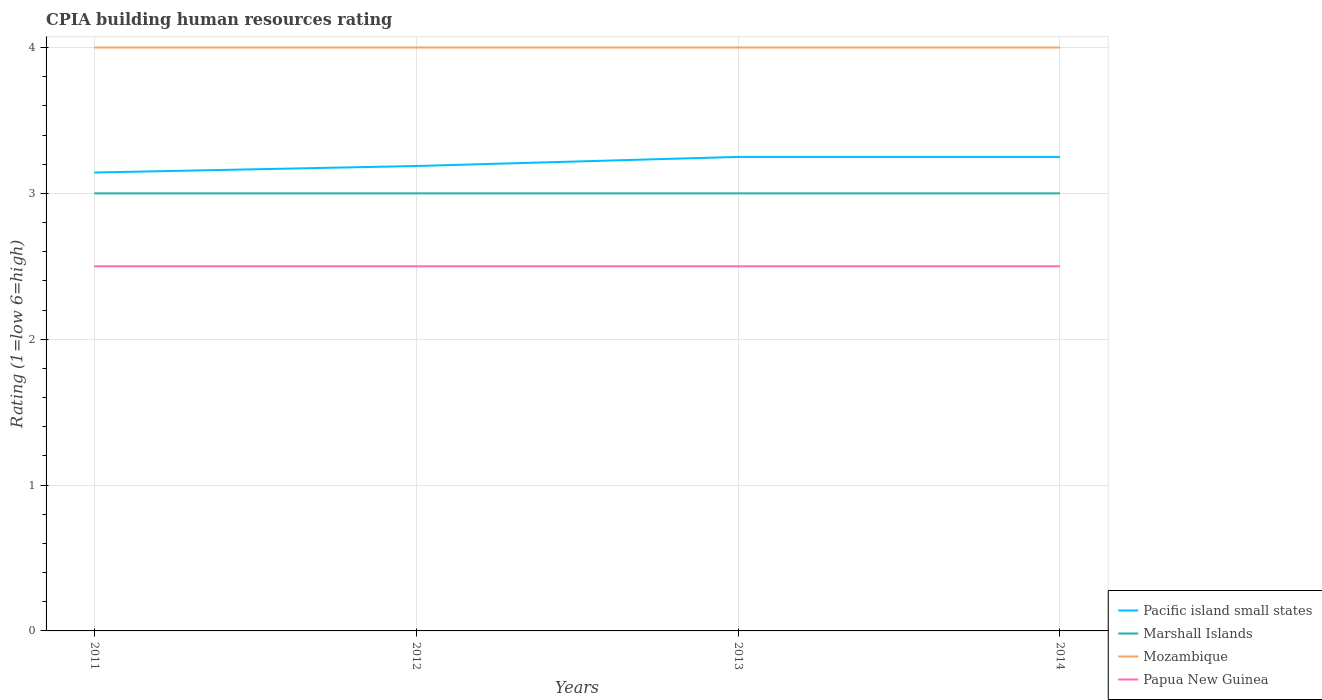How many different coloured lines are there?
Offer a terse response. 4. Is the number of lines equal to the number of legend labels?
Your response must be concise. Yes. What is the total CPIA rating in Pacific island small states in the graph?
Your answer should be compact. -0.11. What is the difference between the highest and the second highest CPIA rating in Marshall Islands?
Ensure brevity in your answer.  0. What is the difference between the highest and the lowest CPIA rating in Mozambique?
Your answer should be very brief. 0. Is the CPIA rating in Mozambique strictly greater than the CPIA rating in Marshall Islands over the years?
Keep it short and to the point. No. How many years are there in the graph?
Keep it short and to the point. 4. What is the difference between two consecutive major ticks on the Y-axis?
Ensure brevity in your answer.  1. Are the values on the major ticks of Y-axis written in scientific E-notation?
Keep it short and to the point. No. Does the graph contain any zero values?
Offer a terse response. No. Does the graph contain grids?
Offer a very short reply. Yes. What is the title of the graph?
Offer a very short reply. CPIA building human resources rating. What is the label or title of the X-axis?
Ensure brevity in your answer.  Years. What is the Rating (1=low 6=high) of Pacific island small states in 2011?
Make the answer very short. 3.14. What is the Rating (1=low 6=high) in Marshall Islands in 2011?
Your answer should be compact. 3. What is the Rating (1=low 6=high) of Papua New Guinea in 2011?
Your answer should be very brief. 2.5. What is the Rating (1=low 6=high) of Pacific island small states in 2012?
Make the answer very short. 3.19. What is the Rating (1=low 6=high) of Mozambique in 2012?
Ensure brevity in your answer.  4. What is the Rating (1=low 6=high) in Pacific island small states in 2013?
Provide a short and direct response. 3.25. What is the Rating (1=low 6=high) of Marshall Islands in 2013?
Your answer should be very brief. 3. What is the Rating (1=low 6=high) in Mozambique in 2013?
Provide a succinct answer. 4. What is the Rating (1=low 6=high) of Papua New Guinea in 2013?
Ensure brevity in your answer.  2.5. Across all years, what is the maximum Rating (1=low 6=high) of Pacific island small states?
Offer a terse response. 3.25. Across all years, what is the minimum Rating (1=low 6=high) in Pacific island small states?
Ensure brevity in your answer.  3.14. Across all years, what is the minimum Rating (1=low 6=high) in Marshall Islands?
Provide a succinct answer. 3. Across all years, what is the minimum Rating (1=low 6=high) in Mozambique?
Ensure brevity in your answer.  4. Across all years, what is the minimum Rating (1=low 6=high) of Papua New Guinea?
Your response must be concise. 2.5. What is the total Rating (1=low 6=high) of Pacific island small states in the graph?
Ensure brevity in your answer.  12.83. What is the total Rating (1=low 6=high) of Marshall Islands in the graph?
Your answer should be very brief. 12. What is the total Rating (1=low 6=high) in Papua New Guinea in the graph?
Offer a terse response. 10. What is the difference between the Rating (1=low 6=high) in Pacific island small states in 2011 and that in 2012?
Your answer should be very brief. -0.04. What is the difference between the Rating (1=low 6=high) of Marshall Islands in 2011 and that in 2012?
Keep it short and to the point. 0. What is the difference between the Rating (1=low 6=high) in Mozambique in 2011 and that in 2012?
Your answer should be compact. 0. What is the difference between the Rating (1=low 6=high) in Pacific island small states in 2011 and that in 2013?
Ensure brevity in your answer.  -0.11. What is the difference between the Rating (1=low 6=high) in Marshall Islands in 2011 and that in 2013?
Your answer should be compact. 0. What is the difference between the Rating (1=low 6=high) in Pacific island small states in 2011 and that in 2014?
Provide a succinct answer. -0.11. What is the difference between the Rating (1=low 6=high) of Papua New Guinea in 2011 and that in 2014?
Your answer should be compact. 0. What is the difference between the Rating (1=low 6=high) of Pacific island small states in 2012 and that in 2013?
Offer a very short reply. -0.06. What is the difference between the Rating (1=low 6=high) of Mozambique in 2012 and that in 2013?
Provide a short and direct response. 0. What is the difference between the Rating (1=low 6=high) in Pacific island small states in 2012 and that in 2014?
Offer a terse response. -0.06. What is the difference between the Rating (1=low 6=high) of Marshall Islands in 2012 and that in 2014?
Your answer should be very brief. 0. What is the difference between the Rating (1=low 6=high) of Mozambique in 2012 and that in 2014?
Provide a short and direct response. 0. What is the difference between the Rating (1=low 6=high) in Marshall Islands in 2013 and that in 2014?
Your response must be concise. 0. What is the difference between the Rating (1=low 6=high) in Mozambique in 2013 and that in 2014?
Make the answer very short. 0. What is the difference between the Rating (1=low 6=high) of Pacific island small states in 2011 and the Rating (1=low 6=high) of Marshall Islands in 2012?
Provide a succinct answer. 0.14. What is the difference between the Rating (1=low 6=high) of Pacific island small states in 2011 and the Rating (1=low 6=high) of Mozambique in 2012?
Provide a succinct answer. -0.86. What is the difference between the Rating (1=low 6=high) in Pacific island small states in 2011 and the Rating (1=low 6=high) in Papua New Guinea in 2012?
Give a very brief answer. 0.64. What is the difference between the Rating (1=low 6=high) in Marshall Islands in 2011 and the Rating (1=low 6=high) in Mozambique in 2012?
Ensure brevity in your answer.  -1. What is the difference between the Rating (1=low 6=high) in Marshall Islands in 2011 and the Rating (1=low 6=high) in Papua New Guinea in 2012?
Your answer should be very brief. 0.5. What is the difference between the Rating (1=low 6=high) in Pacific island small states in 2011 and the Rating (1=low 6=high) in Marshall Islands in 2013?
Offer a terse response. 0.14. What is the difference between the Rating (1=low 6=high) in Pacific island small states in 2011 and the Rating (1=low 6=high) in Mozambique in 2013?
Provide a short and direct response. -0.86. What is the difference between the Rating (1=low 6=high) in Pacific island small states in 2011 and the Rating (1=low 6=high) in Papua New Guinea in 2013?
Ensure brevity in your answer.  0.64. What is the difference between the Rating (1=low 6=high) of Marshall Islands in 2011 and the Rating (1=low 6=high) of Papua New Guinea in 2013?
Provide a short and direct response. 0.5. What is the difference between the Rating (1=low 6=high) in Pacific island small states in 2011 and the Rating (1=low 6=high) in Marshall Islands in 2014?
Keep it short and to the point. 0.14. What is the difference between the Rating (1=low 6=high) of Pacific island small states in 2011 and the Rating (1=low 6=high) of Mozambique in 2014?
Offer a terse response. -0.86. What is the difference between the Rating (1=low 6=high) in Pacific island small states in 2011 and the Rating (1=low 6=high) in Papua New Guinea in 2014?
Make the answer very short. 0.64. What is the difference between the Rating (1=low 6=high) in Marshall Islands in 2011 and the Rating (1=low 6=high) in Mozambique in 2014?
Offer a terse response. -1. What is the difference between the Rating (1=low 6=high) in Marshall Islands in 2011 and the Rating (1=low 6=high) in Papua New Guinea in 2014?
Make the answer very short. 0.5. What is the difference between the Rating (1=low 6=high) of Mozambique in 2011 and the Rating (1=low 6=high) of Papua New Guinea in 2014?
Ensure brevity in your answer.  1.5. What is the difference between the Rating (1=low 6=high) of Pacific island small states in 2012 and the Rating (1=low 6=high) of Marshall Islands in 2013?
Provide a succinct answer. 0.19. What is the difference between the Rating (1=low 6=high) of Pacific island small states in 2012 and the Rating (1=low 6=high) of Mozambique in 2013?
Ensure brevity in your answer.  -0.81. What is the difference between the Rating (1=low 6=high) in Pacific island small states in 2012 and the Rating (1=low 6=high) in Papua New Guinea in 2013?
Offer a terse response. 0.69. What is the difference between the Rating (1=low 6=high) of Marshall Islands in 2012 and the Rating (1=low 6=high) of Papua New Guinea in 2013?
Provide a short and direct response. 0.5. What is the difference between the Rating (1=low 6=high) of Pacific island small states in 2012 and the Rating (1=low 6=high) of Marshall Islands in 2014?
Provide a short and direct response. 0.19. What is the difference between the Rating (1=low 6=high) in Pacific island small states in 2012 and the Rating (1=low 6=high) in Mozambique in 2014?
Ensure brevity in your answer.  -0.81. What is the difference between the Rating (1=low 6=high) in Pacific island small states in 2012 and the Rating (1=low 6=high) in Papua New Guinea in 2014?
Offer a terse response. 0.69. What is the difference between the Rating (1=low 6=high) in Marshall Islands in 2012 and the Rating (1=low 6=high) in Papua New Guinea in 2014?
Your response must be concise. 0.5. What is the difference between the Rating (1=low 6=high) in Pacific island small states in 2013 and the Rating (1=low 6=high) in Marshall Islands in 2014?
Give a very brief answer. 0.25. What is the difference between the Rating (1=low 6=high) in Pacific island small states in 2013 and the Rating (1=low 6=high) in Mozambique in 2014?
Your response must be concise. -0.75. What is the difference between the Rating (1=low 6=high) in Pacific island small states in 2013 and the Rating (1=low 6=high) in Papua New Guinea in 2014?
Ensure brevity in your answer.  0.75. What is the difference between the Rating (1=low 6=high) of Marshall Islands in 2013 and the Rating (1=low 6=high) of Mozambique in 2014?
Offer a terse response. -1. What is the average Rating (1=low 6=high) of Pacific island small states per year?
Your answer should be compact. 3.21. What is the average Rating (1=low 6=high) in Mozambique per year?
Offer a terse response. 4. What is the average Rating (1=low 6=high) of Papua New Guinea per year?
Make the answer very short. 2.5. In the year 2011, what is the difference between the Rating (1=low 6=high) of Pacific island small states and Rating (1=low 6=high) of Marshall Islands?
Provide a succinct answer. 0.14. In the year 2011, what is the difference between the Rating (1=low 6=high) in Pacific island small states and Rating (1=low 6=high) in Mozambique?
Provide a succinct answer. -0.86. In the year 2011, what is the difference between the Rating (1=low 6=high) of Pacific island small states and Rating (1=low 6=high) of Papua New Guinea?
Your answer should be very brief. 0.64. In the year 2012, what is the difference between the Rating (1=low 6=high) in Pacific island small states and Rating (1=low 6=high) in Marshall Islands?
Your answer should be compact. 0.19. In the year 2012, what is the difference between the Rating (1=low 6=high) in Pacific island small states and Rating (1=low 6=high) in Mozambique?
Make the answer very short. -0.81. In the year 2012, what is the difference between the Rating (1=low 6=high) in Pacific island small states and Rating (1=low 6=high) in Papua New Guinea?
Ensure brevity in your answer.  0.69. In the year 2012, what is the difference between the Rating (1=low 6=high) in Marshall Islands and Rating (1=low 6=high) in Mozambique?
Your answer should be compact. -1. In the year 2012, what is the difference between the Rating (1=low 6=high) of Marshall Islands and Rating (1=low 6=high) of Papua New Guinea?
Make the answer very short. 0.5. In the year 2013, what is the difference between the Rating (1=low 6=high) in Pacific island small states and Rating (1=low 6=high) in Marshall Islands?
Keep it short and to the point. 0.25. In the year 2013, what is the difference between the Rating (1=low 6=high) of Pacific island small states and Rating (1=low 6=high) of Mozambique?
Offer a terse response. -0.75. In the year 2013, what is the difference between the Rating (1=low 6=high) in Marshall Islands and Rating (1=low 6=high) in Mozambique?
Your answer should be very brief. -1. In the year 2014, what is the difference between the Rating (1=low 6=high) of Pacific island small states and Rating (1=low 6=high) of Marshall Islands?
Offer a terse response. 0.25. In the year 2014, what is the difference between the Rating (1=low 6=high) in Pacific island small states and Rating (1=low 6=high) in Mozambique?
Provide a succinct answer. -0.75. In the year 2014, what is the difference between the Rating (1=low 6=high) in Pacific island small states and Rating (1=low 6=high) in Papua New Guinea?
Your response must be concise. 0.75. In the year 2014, what is the difference between the Rating (1=low 6=high) of Marshall Islands and Rating (1=low 6=high) of Papua New Guinea?
Keep it short and to the point. 0.5. What is the ratio of the Rating (1=low 6=high) in Pacific island small states in 2011 to that in 2012?
Give a very brief answer. 0.99. What is the ratio of the Rating (1=low 6=high) of Marshall Islands in 2011 to that in 2012?
Your response must be concise. 1. What is the ratio of the Rating (1=low 6=high) in Pacific island small states in 2011 to that in 2013?
Ensure brevity in your answer.  0.97. What is the ratio of the Rating (1=low 6=high) of Marshall Islands in 2011 to that in 2013?
Keep it short and to the point. 1. What is the ratio of the Rating (1=low 6=high) in Pacific island small states in 2011 to that in 2014?
Offer a very short reply. 0.97. What is the ratio of the Rating (1=low 6=high) in Papua New Guinea in 2011 to that in 2014?
Keep it short and to the point. 1. What is the ratio of the Rating (1=low 6=high) of Pacific island small states in 2012 to that in 2013?
Provide a short and direct response. 0.98. What is the ratio of the Rating (1=low 6=high) of Marshall Islands in 2012 to that in 2013?
Make the answer very short. 1. What is the ratio of the Rating (1=low 6=high) of Mozambique in 2012 to that in 2013?
Your answer should be compact. 1. What is the ratio of the Rating (1=low 6=high) of Papua New Guinea in 2012 to that in 2013?
Keep it short and to the point. 1. What is the ratio of the Rating (1=low 6=high) in Pacific island small states in 2012 to that in 2014?
Provide a succinct answer. 0.98. What is the ratio of the Rating (1=low 6=high) of Marshall Islands in 2012 to that in 2014?
Keep it short and to the point. 1. What is the ratio of the Rating (1=low 6=high) of Marshall Islands in 2013 to that in 2014?
Make the answer very short. 1. What is the ratio of the Rating (1=low 6=high) of Papua New Guinea in 2013 to that in 2014?
Provide a succinct answer. 1. What is the difference between the highest and the second highest Rating (1=low 6=high) in Pacific island small states?
Your answer should be compact. 0. What is the difference between the highest and the lowest Rating (1=low 6=high) of Pacific island small states?
Your answer should be compact. 0.11. What is the difference between the highest and the lowest Rating (1=low 6=high) in Papua New Guinea?
Make the answer very short. 0. 